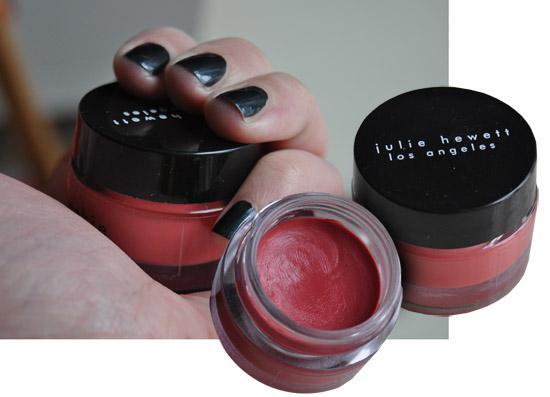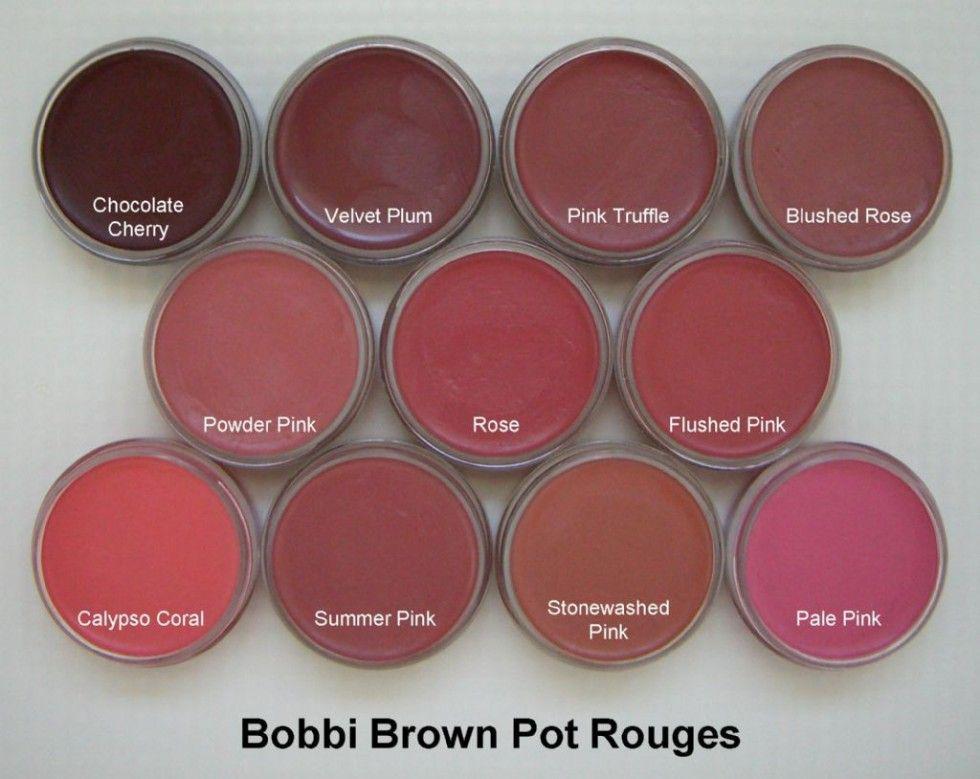The first image is the image on the left, the second image is the image on the right. Evaluate the accuracy of this statement regarding the images: "Each image contains exactly four round disc-shaped items.". Is it true? Answer yes or no. No. The first image is the image on the left, the second image is the image on the right. Considering the images on both sides, is "There are two open makeup with their lids next to them in the right image." valid? Answer yes or no. No. 